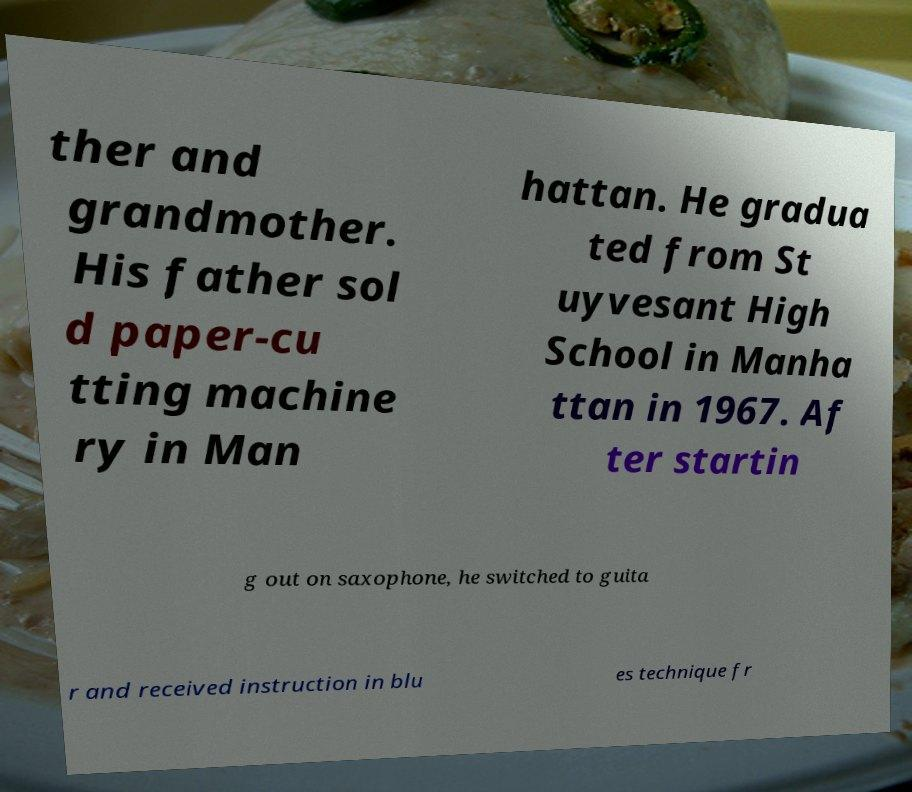Please identify and transcribe the text found in this image. ther and grandmother. His father sol d paper-cu tting machine ry in Man hattan. He gradua ted from St uyvesant High School in Manha ttan in 1967. Af ter startin g out on saxophone, he switched to guita r and received instruction in blu es technique fr 